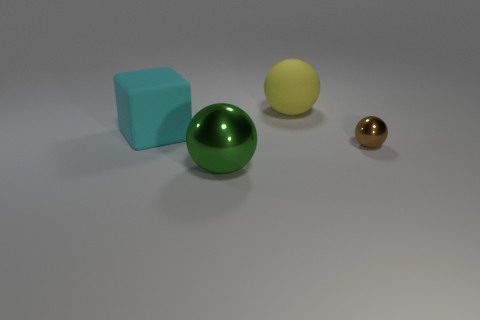Is the big yellow object made of the same material as the green ball?
Keep it short and to the point. No. Are there any other things that have the same size as the green sphere?
Provide a short and direct response. Yes. What number of matte things are left of the large green metal sphere?
Provide a short and direct response. 1. What is the shape of the metal object that is left of the metallic ball right of the green object?
Provide a succinct answer. Sphere. Is there anything else that has the same shape as the brown metallic object?
Provide a short and direct response. Yes. Are there more large metal spheres that are behind the brown ball than large matte balls?
Your answer should be very brief. No. There is a shiny thing on the left side of the small sphere; what number of big objects are behind it?
Your response must be concise. 2. There is a big object that is in front of the metallic ball right of the large ball that is on the right side of the big metal object; what shape is it?
Your response must be concise. Sphere. The cyan matte block is what size?
Give a very brief answer. Large. Are there any other big cyan cubes that have the same material as the cyan block?
Offer a very short reply. No. 